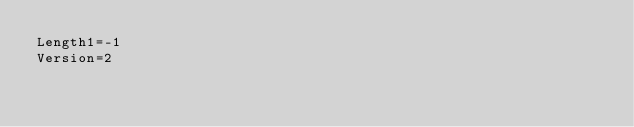<code> <loc_0><loc_0><loc_500><loc_500><_SQL_>Length1=-1
Version=2
</code> 